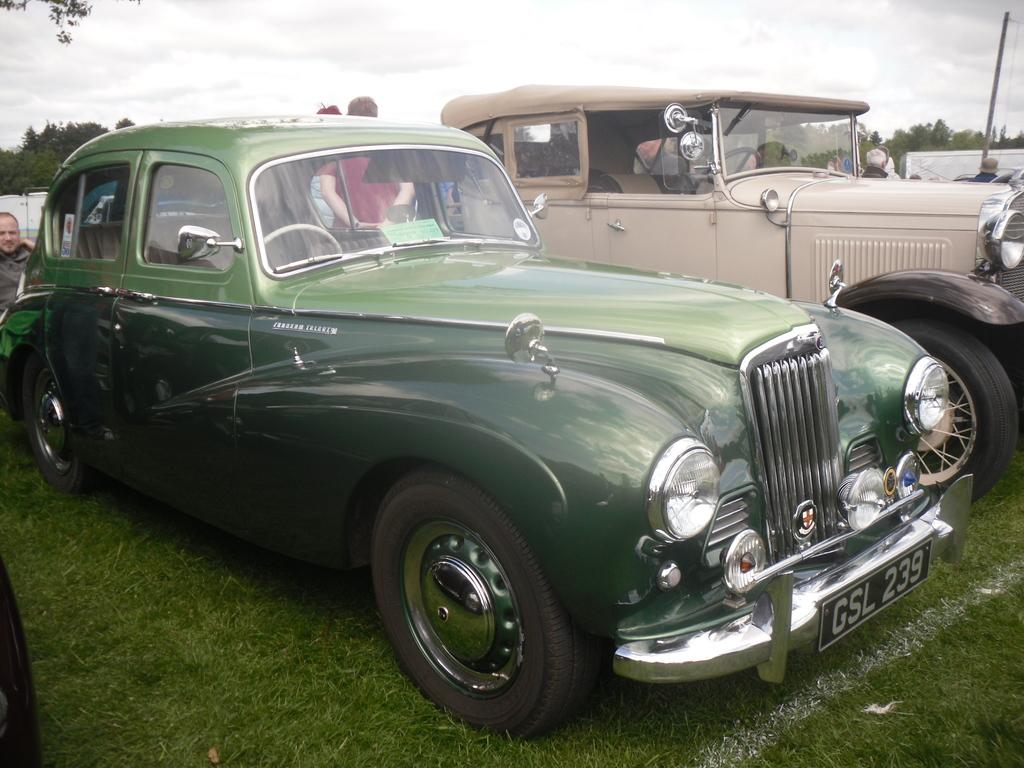What is located in the center of the image? There are cars on the grass in the center of the image. What can be seen in the background of the image? There is sky and trees visible in the background of the image. Are there any people present in the image? Yes, there are people present in the image. What type of side dish is being served on the side of the cars in the image? There is no side dish present in the image; it features cars on the grass with people and a background of sky and trees. 